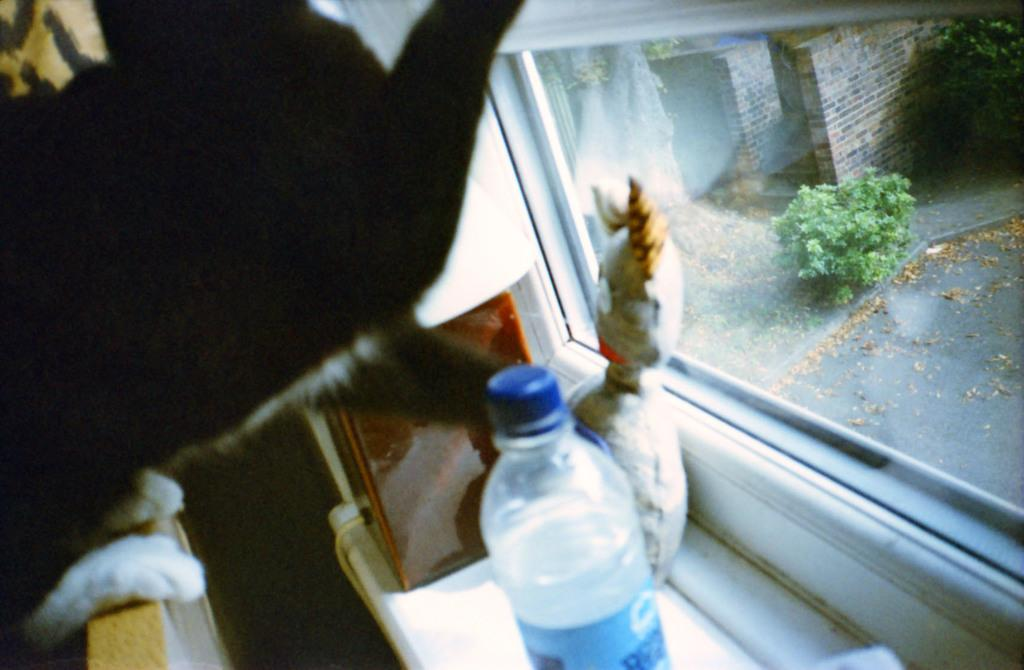What object can be seen in the image that is used for holding water? There is a water bottle in the image. What architectural feature is present in the image? There is a window in the image. What can be seen through the window? A plant and a brick building are visible through the window. How does the sense of loss affect the dolls in the image? There are no dolls present in the image, so the concept of loss does not apply. 